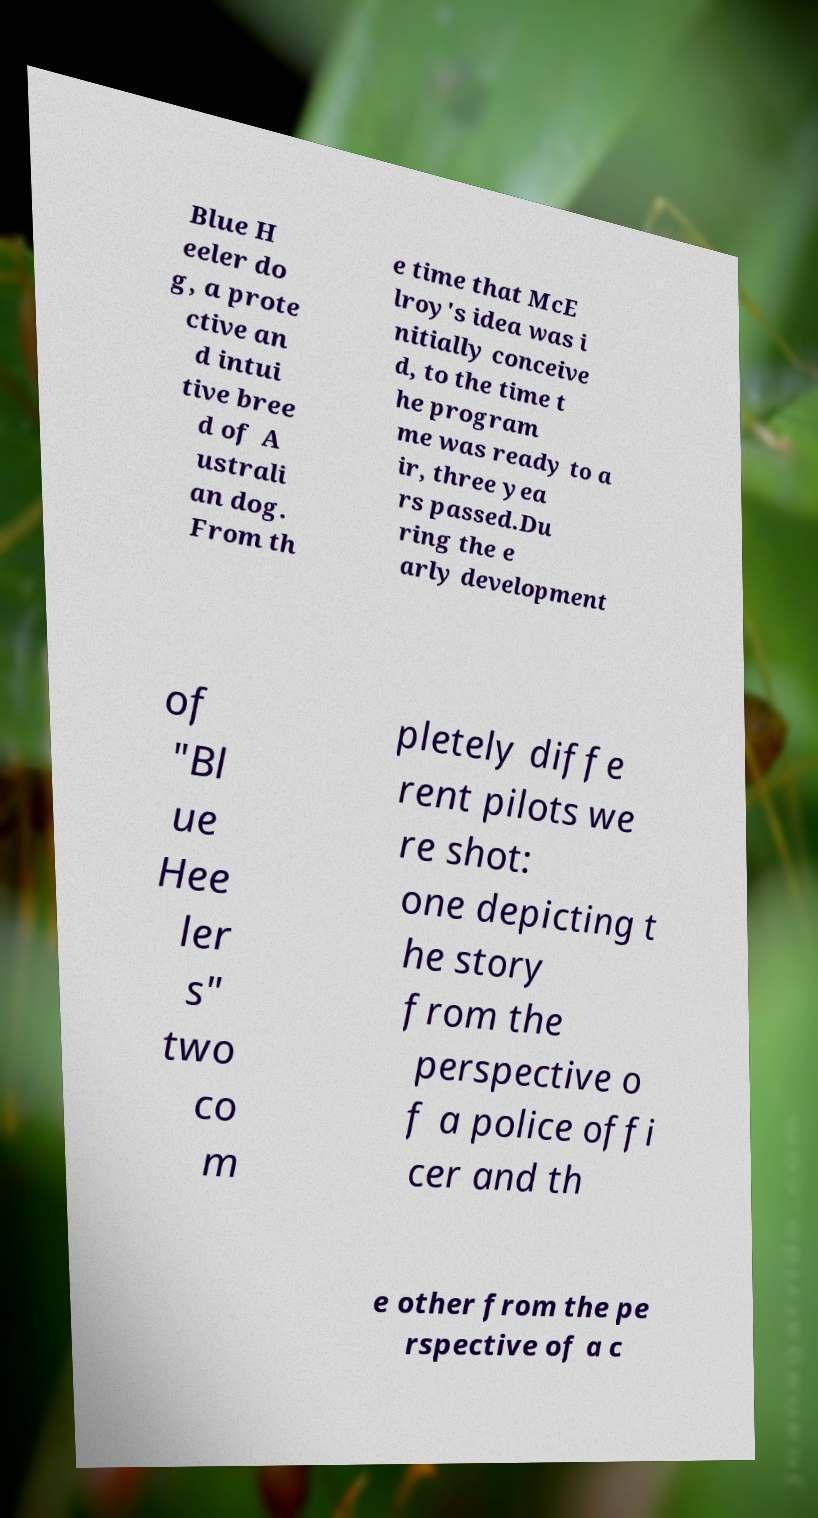What messages or text are displayed in this image? I need them in a readable, typed format. Blue H eeler do g, a prote ctive an d intui tive bree d of A ustrali an dog. From th e time that McE lroy's idea was i nitially conceive d, to the time t he program me was ready to a ir, three yea rs passed.Du ring the e arly development of "Bl ue Hee ler s" two co m pletely diffe rent pilots we re shot: one depicting t he story from the perspective o f a police offi cer and th e other from the pe rspective of a c 